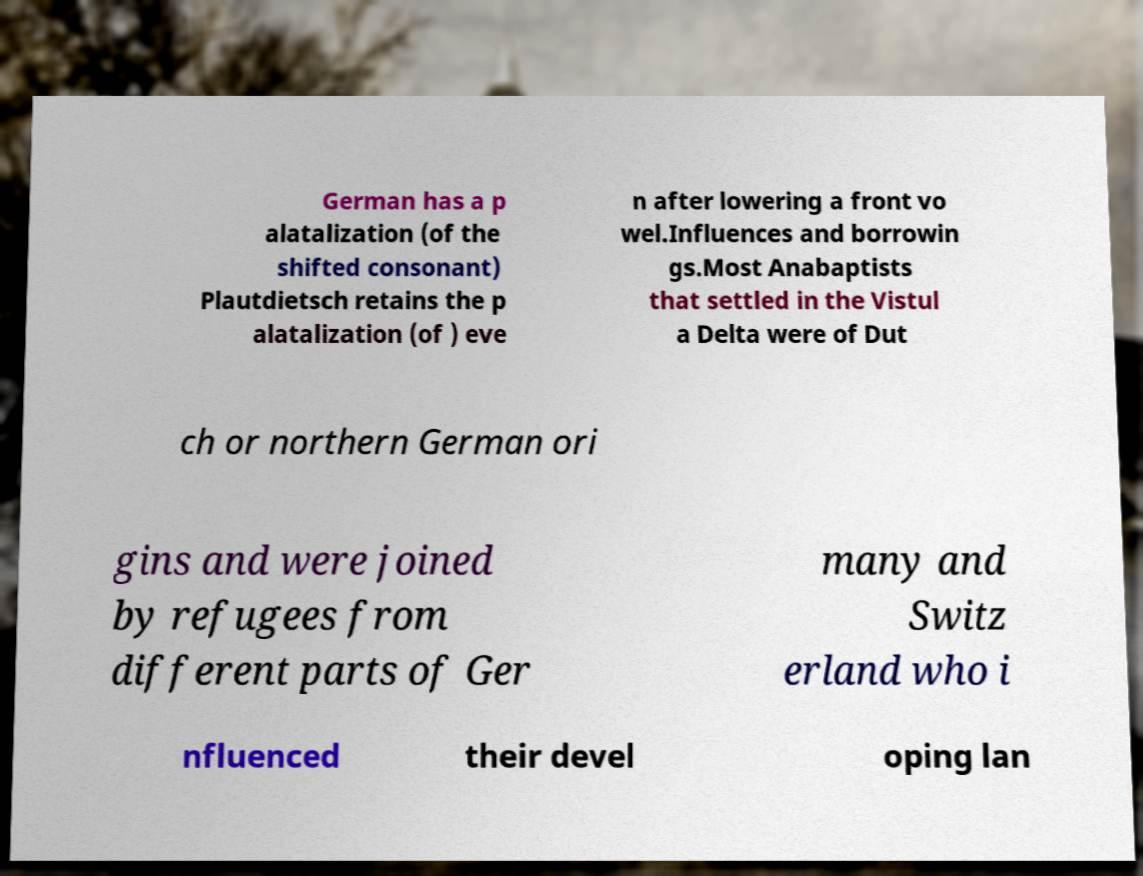Please identify and transcribe the text found in this image. German has a p alatalization (of the shifted consonant) Plautdietsch retains the p alatalization (of ) eve n after lowering a front vo wel.Influences and borrowin gs.Most Anabaptists that settled in the Vistul a Delta were of Dut ch or northern German ori gins and were joined by refugees from different parts of Ger many and Switz erland who i nfluenced their devel oping lan 